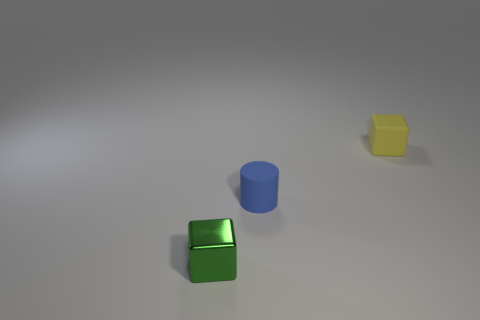Add 3 green cubes. How many objects exist? 6 Subtract all cylinders. How many objects are left? 2 Subtract all yellow blocks. How many blocks are left? 1 Add 1 matte cubes. How many matte cubes are left? 2 Add 2 tiny yellow objects. How many tiny yellow objects exist? 3 Subtract 0 yellow spheres. How many objects are left? 3 Subtract all purple cylinders. Subtract all cyan blocks. How many cylinders are left? 1 Subtract all rubber objects. Subtract all tiny green things. How many objects are left? 0 